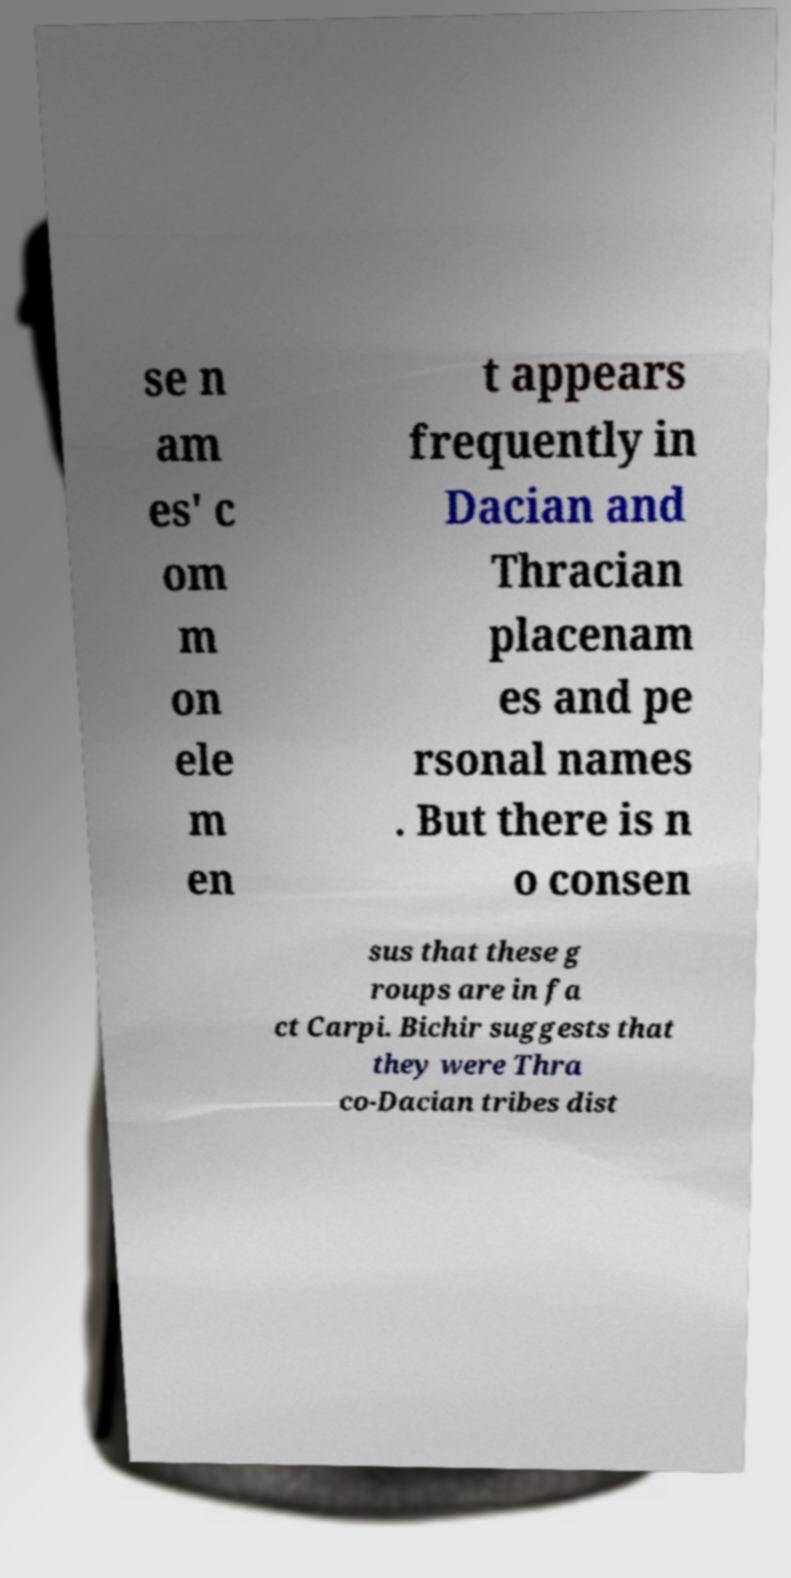Can you read and provide the text displayed in the image?This photo seems to have some interesting text. Can you extract and type it out for me? se n am es' c om m on ele m en t appears frequently in Dacian and Thracian placenam es and pe rsonal names . But there is n o consen sus that these g roups are in fa ct Carpi. Bichir suggests that they were Thra co-Dacian tribes dist 